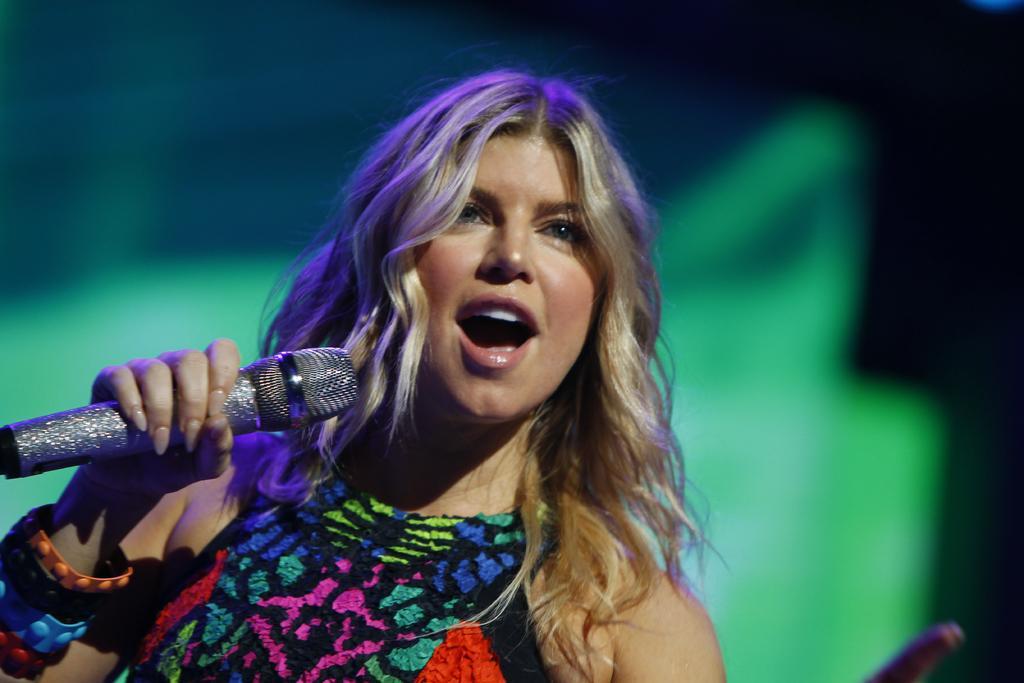In one or two sentences, can you explain what this image depicts? There is a woman singing in the picture. The woman wore a colorful dress and wrist bands to her hand. She is holding a microphone and the holder of it is shinny. The background is blurred. 